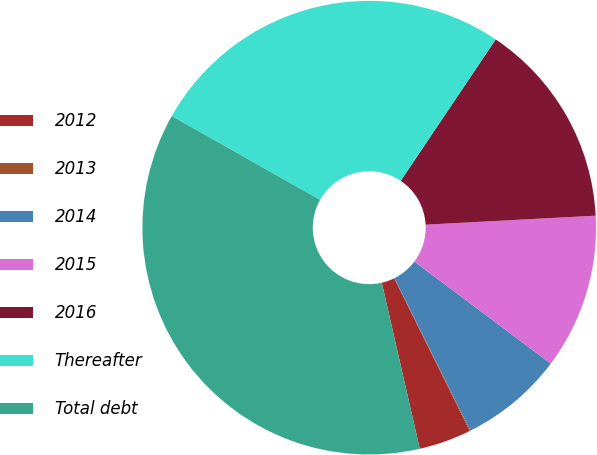<chart> <loc_0><loc_0><loc_500><loc_500><pie_chart><fcel>2012<fcel>2013<fcel>2014<fcel>2015<fcel>2016<fcel>Thereafter<fcel>Total debt<nl><fcel>3.73%<fcel>0.06%<fcel>7.4%<fcel>11.07%<fcel>14.74%<fcel>26.22%<fcel>36.76%<nl></chart> 